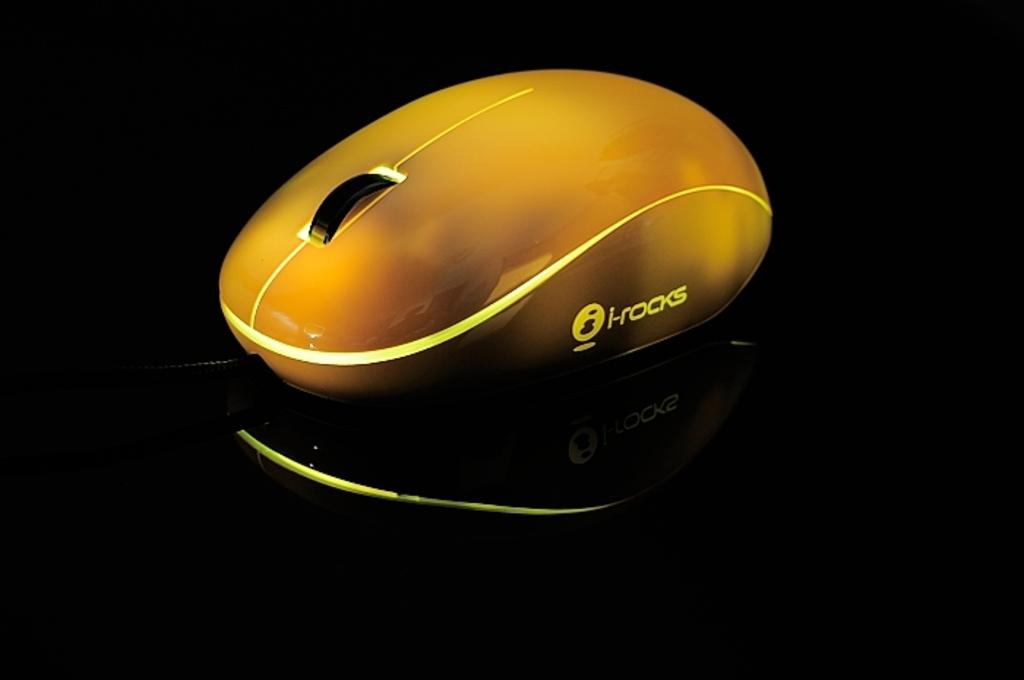What type of animal is in the image? There is a yellow color mouse in the image. What color is the surface the mouse is on? The mouse is on a black color surface. What type of mist can be seen surrounding the mouse in the image? There is no mist present in the image; it only features a yellow color mouse on a black color surface. 